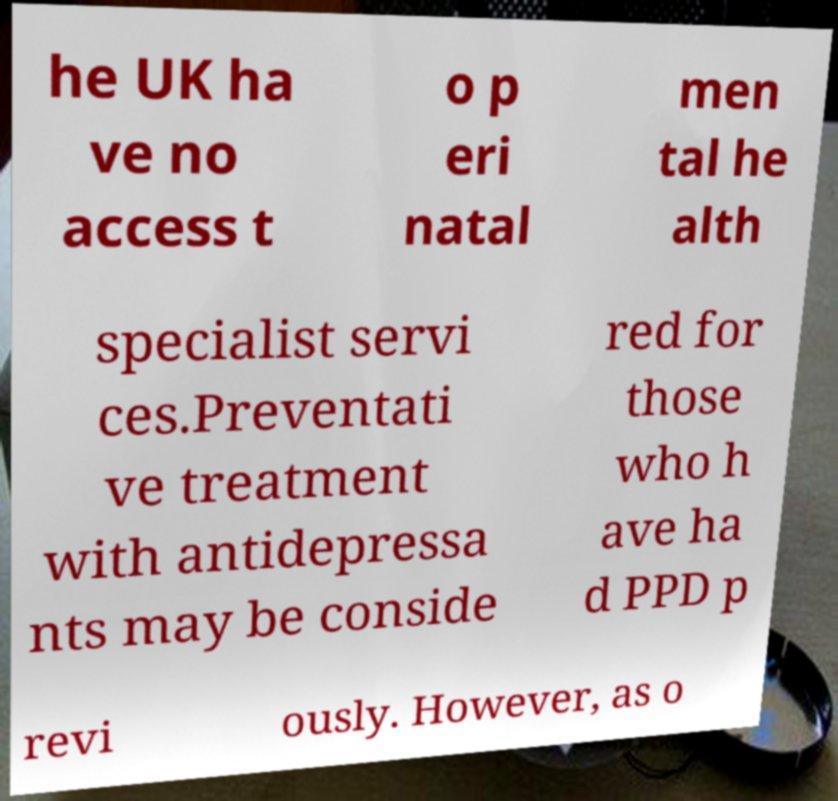What messages or text are displayed in this image? I need them in a readable, typed format. he UK ha ve no access t o p eri natal men tal he alth specialist servi ces.Preventati ve treatment with antidepressa nts may be conside red for those who h ave ha d PPD p revi ously. However, as o 